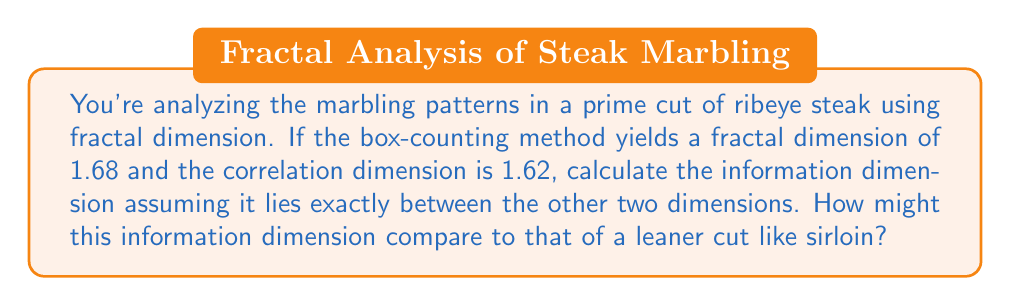Can you answer this question? Let's approach this step-by-step:

1) We're given two dimensions:
   - Box-counting dimension: $D_B = 1.68$
   - Correlation dimension: $D_C = 1.62$

2) In fractal analysis, these dimensions typically follow the inequality:
   $D_C \leq D_I \leq D_B$
   where $D_I$ is the information dimension.

3) We're told that $D_I$ lies exactly between $D_C$ and $D_B$. This means we can calculate it as the average of these two values:

   $D_I = \frac{D_C + D_B}{2}$

4) Substituting the values:

   $D_I = \frac{1.62 + 1.68}{2} = \frac{3.30}{2} = 1.65$

5) Regarding comparison with a leaner cut like sirloin:
   - Ribeye typically has more intricate marbling patterns than sirloin.
   - More complex patterns generally result in higher fractal dimensions.
   - Therefore, we would expect the information dimension (and other fractal dimensions) of a sirloin to be lower than that of a ribeye.
   - A hypothetical value for sirloin might be closer to 1.5, indicating less complexity in its marbling pattern.

This analysis provides insight into the complexity of fat distribution in different cuts of meat, which directly relates to flavor and texture differences that a chef would be interested in.
Answer: $D_I = 1.65$ 